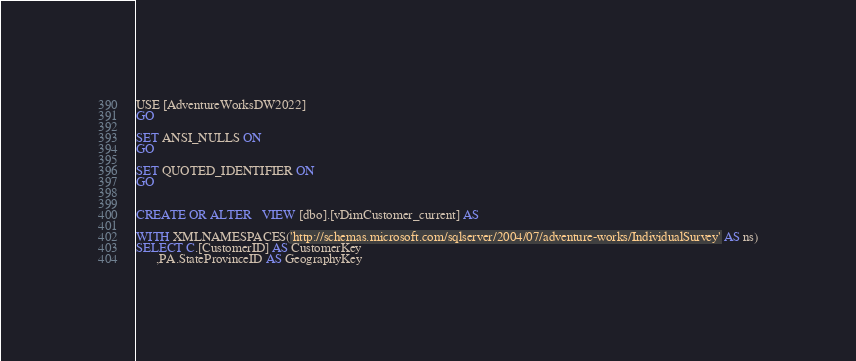Convert code to text. <code><loc_0><loc_0><loc_500><loc_500><_SQL_>USE [AdventureWorksDW2022]
GO

SET ANSI_NULLS ON
GO

SET QUOTED_IDENTIFIER ON
GO


CREATE OR ALTER   VIEW [dbo].[vDimCustomer_current] AS

WITH XMLNAMESPACES('http://schemas.microsoft.com/sqlserver/2004/07/adventure-works/IndividualSurvey' AS ns)
SELECT C.[CustomerID] AS CustomerKey
	  ,PA.StateProvinceID AS GeographyKey</code> 